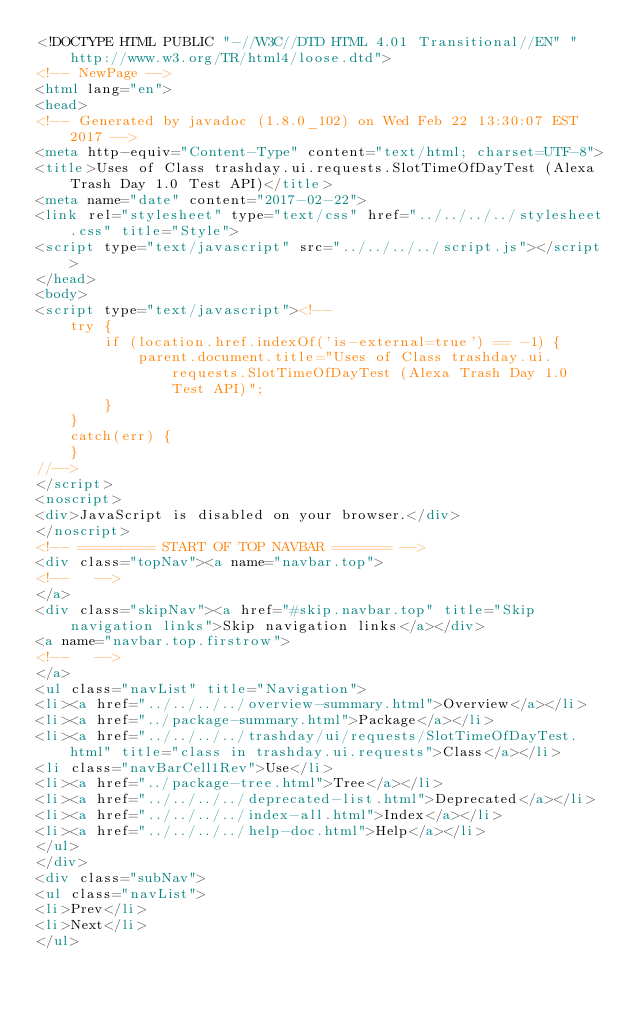Convert code to text. <code><loc_0><loc_0><loc_500><loc_500><_HTML_><!DOCTYPE HTML PUBLIC "-//W3C//DTD HTML 4.01 Transitional//EN" "http://www.w3.org/TR/html4/loose.dtd">
<!-- NewPage -->
<html lang="en">
<head>
<!-- Generated by javadoc (1.8.0_102) on Wed Feb 22 13:30:07 EST 2017 -->
<meta http-equiv="Content-Type" content="text/html; charset=UTF-8">
<title>Uses of Class trashday.ui.requests.SlotTimeOfDayTest (Alexa Trash Day 1.0 Test API)</title>
<meta name="date" content="2017-02-22">
<link rel="stylesheet" type="text/css" href="../../../../stylesheet.css" title="Style">
<script type="text/javascript" src="../../../../script.js"></script>
</head>
<body>
<script type="text/javascript"><!--
    try {
        if (location.href.indexOf('is-external=true') == -1) {
            parent.document.title="Uses of Class trashday.ui.requests.SlotTimeOfDayTest (Alexa Trash Day 1.0 Test API)";
        }
    }
    catch(err) {
    }
//-->
</script>
<noscript>
<div>JavaScript is disabled on your browser.</div>
</noscript>
<!-- ========= START OF TOP NAVBAR ======= -->
<div class="topNav"><a name="navbar.top">
<!--   -->
</a>
<div class="skipNav"><a href="#skip.navbar.top" title="Skip navigation links">Skip navigation links</a></div>
<a name="navbar.top.firstrow">
<!--   -->
</a>
<ul class="navList" title="Navigation">
<li><a href="../../../../overview-summary.html">Overview</a></li>
<li><a href="../package-summary.html">Package</a></li>
<li><a href="../../../../trashday/ui/requests/SlotTimeOfDayTest.html" title="class in trashday.ui.requests">Class</a></li>
<li class="navBarCell1Rev">Use</li>
<li><a href="../package-tree.html">Tree</a></li>
<li><a href="../../../../deprecated-list.html">Deprecated</a></li>
<li><a href="../../../../index-all.html">Index</a></li>
<li><a href="../../../../help-doc.html">Help</a></li>
</ul>
</div>
<div class="subNav">
<ul class="navList">
<li>Prev</li>
<li>Next</li>
</ul></code> 